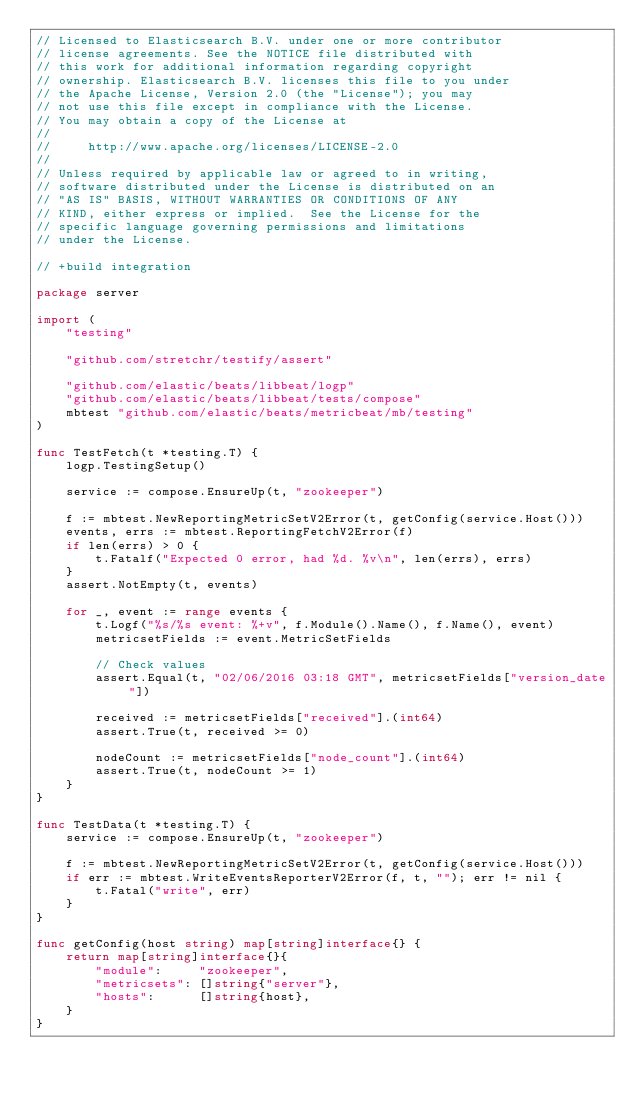Convert code to text. <code><loc_0><loc_0><loc_500><loc_500><_Go_>// Licensed to Elasticsearch B.V. under one or more contributor
// license agreements. See the NOTICE file distributed with
// this work for additional information regarding copyright
// ownership. Elasticsearch B.V. licenses this file to you under
// the Apache License, Version 2.0 (the "License"); you may
// not use this file except in compliance with the License.
// You may obtain a copy of the License at
//
//     http://www.apache.org/licenses/LICENSE-2.0
//
// Unless required by applicable law or agreed to in writing,
// software distributed under the License is distributed on an
// "AS IS" BASIS, WITHOUT WARRANTIES OR CONDITIONS OF ANY
// KIND, either express or implied.  See the License for the
// specific language governing permissions and limitations
// under the License.

// +build integration

package server

import (
	"testing"

	"github.com/stretchr/testify/assert"

	"github.com/elastic/beats/libbeat/logp"
	"github.com/elastic/beats/libbeat/tests/compose"
	mbtest "github.com/elastic/beats/metricbeat/mb/testing"
)

func TestFetch(t *testing.T) {
	logp.TestingSetup()

	service := compose.EnsureUp(t, "zookeeper")

	f := mbtest.NewReportingMetricSetV2Error(t, getConfig(service.Host()))
	events, errs := mbtest.ReportingFetchV2Error(f)
	if len(errs) > 0 {
		t.Fatalf("Expected 0 error, had %d. %v\n", len(errs), errs)
	}
	assert.NotEmpty(t, events)

	for _, event := range events {
		t.Logf("%s/%s event: %+v", f.Module().Name(), f.Name(), event)
		metricsetFields := event.MetricSetFields

		// Check values
		assert.Equal(t, "02/06/2016 03:18 GMT", metricsetFields["version_date"])

		received := metricsetFields["received"].(int64)
		assert.True(t, received >= 0)

		nodeCount := metricsetFields["node_count"].(int64)
		assert.True(t, nodeCount >= 1)
	}
}

func TestData(t *testing.T) {
	service := compose.EnsureUp(t, "zookeeper")

	f := mbtest.NewReportingMetricSetV2Error(t, getConfig(service.Host()))
	if err := mbtest.WriteEventsReporterV2Error(f, t, ""); err != nil {
		t.Fatal("write", err)
	}
}

func getConfig(host string) map[string]interface{} {
	return map[string]interface{}{
		"module":     "zookeeper",
		"metricsets": []string{"server"},
		"hosts":      []string{host},
	}
}
</code> 